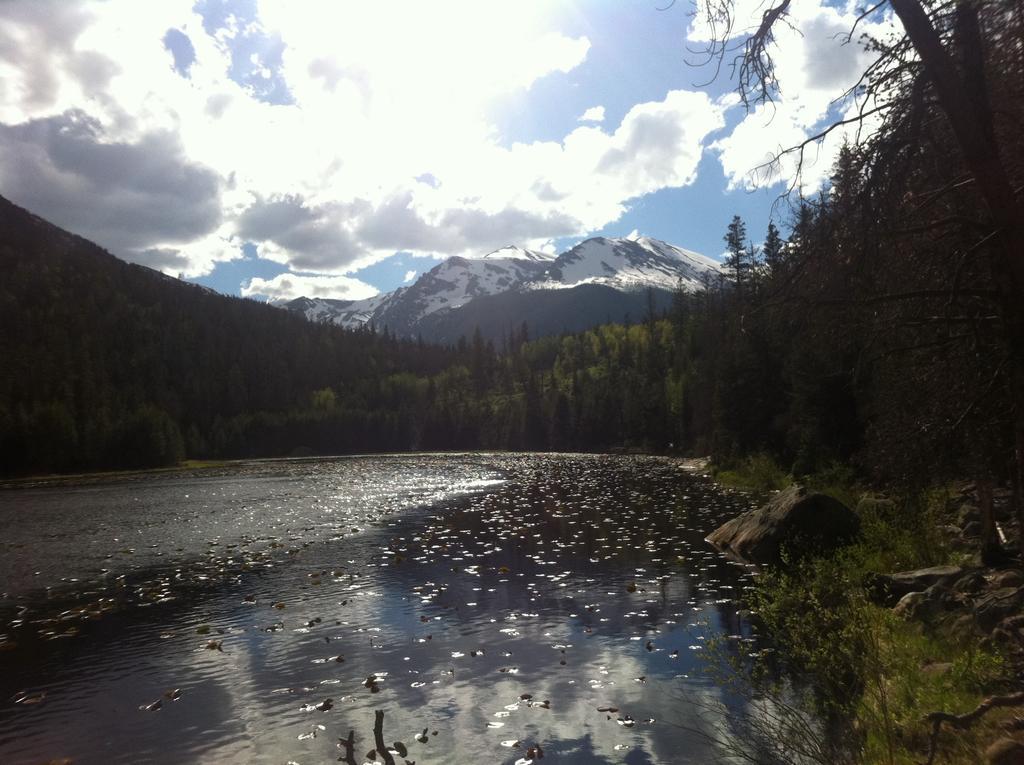Can you describe this image briefly? In the picture we can see water with some dried leaves on it and around it we can see the grass surface with trees and in the background, we can see mountains with snow and behind it we can see the sky with clouds. 